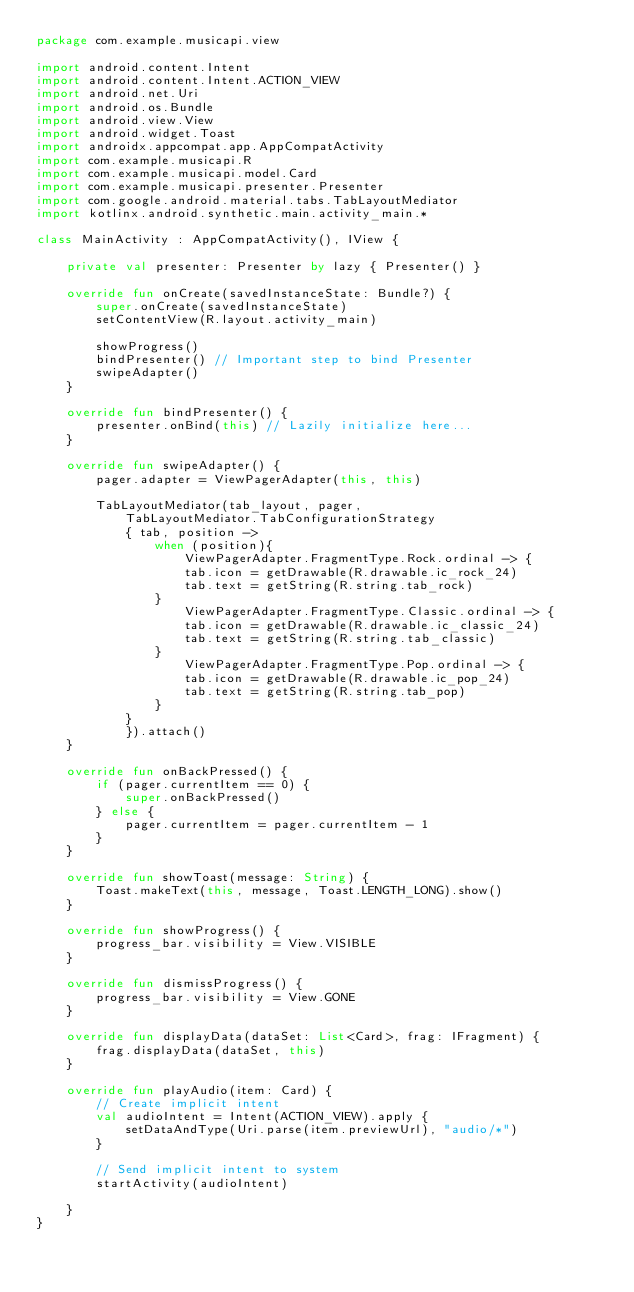<code> <loc_0><loc_0><loc_500><loc_500><_Kotlin_>package com.example.musicapi.view

import android.content.Intent
import android.content.Intent.ACTION_VIEW
import android.net.Uri
import android.os.Bundle
import android.view.View
import android.widget.Toast
import androidx.appcompat.app.AppCompatActivity
import com.example.musicapi.R
import com.example.musicapi.model.Card
import com.example.musicapi.presenter.Presenter
import com.google.android.material.tabs.TabLayoutMediator
import kotlinx.android.synthetic.main.activity_main.*

class MainActivity : AppCompatActivity(), IView {

    private val presenter: Presenter by lazy { Presenter() }

    override fun onCreate(savedInstanceState: Bundle?) {
        super.onCreate(savedInstanceState)
        setContentView(R.layout.activity_main)

        showProgress()
        bindPresenter() // Important step to bind Presenter
        swipeAdapter()
    }

    override fun bindPresenter() {
        presenter.onBind(this) // Lazily initialize here...
    }

    override fun swipeAdapter() {
        pager.adapter = ViewPagerAdapter(this, this)

        TabLayoutMediator(tab_layout, pager,
            TabLayoutMediator.TabConfigurationStrategy
            { tab, position ->
                when (position){
                    ViewPagerAdapter.FragmentType.Rock.ordinal -> {
                    tab.icon = getDrawable(R.drawable.ic_rock_24)
                    tab.text = getString(R.string.tab_rock)
                }
                    ViewPagerAdapter.FragmentType.Classic.ordinal -> {
                    tab.icon = getDrawable(R.drawable.ic_classic_24)
                    tab.text = getString(R.string.tab_classic)
                }
                    ViewPagerAdapter.FragmentType.Pop.ordinal -> {
                    tab.icon = getDrawable(R.drawable.ic_pop_24)
                    tab.text = getString(R.string.tab_pop)
                }
            }
            }).attach()
    }

    override fun onBackPressed() {
        if (pager.currentItem == 0) {
            super.onBackPressed()
        } else {
            pager.currentItem = pager.currentItem - 1
        }
    }

    override fun showToast(message: String) {
        Toast.makeText(this, message, Toast.LENGTH_LONG).show()
    }

    override fun showProgress() {
        progress_bar.visibility = View.VISIBLE
    }

    override fun dismissProgress() {
        progress_bar.visibility = View.GONE
    }

    override fun displayData(dataSet: List<Card>, frag: IFragment) {
        frag.displayData(dataSet, this)
    }

    override fun playAudio(item: Card) {
        // Create implicit intent
        val audioIntent = Intent(ACTION_VIEW).apply {
            setDataAndType(Uri.parse(item.previewUrl), "audio/*")
        }

        // Send implicit intent to system
        startActivity(audioIntent)

    }
}</code> 